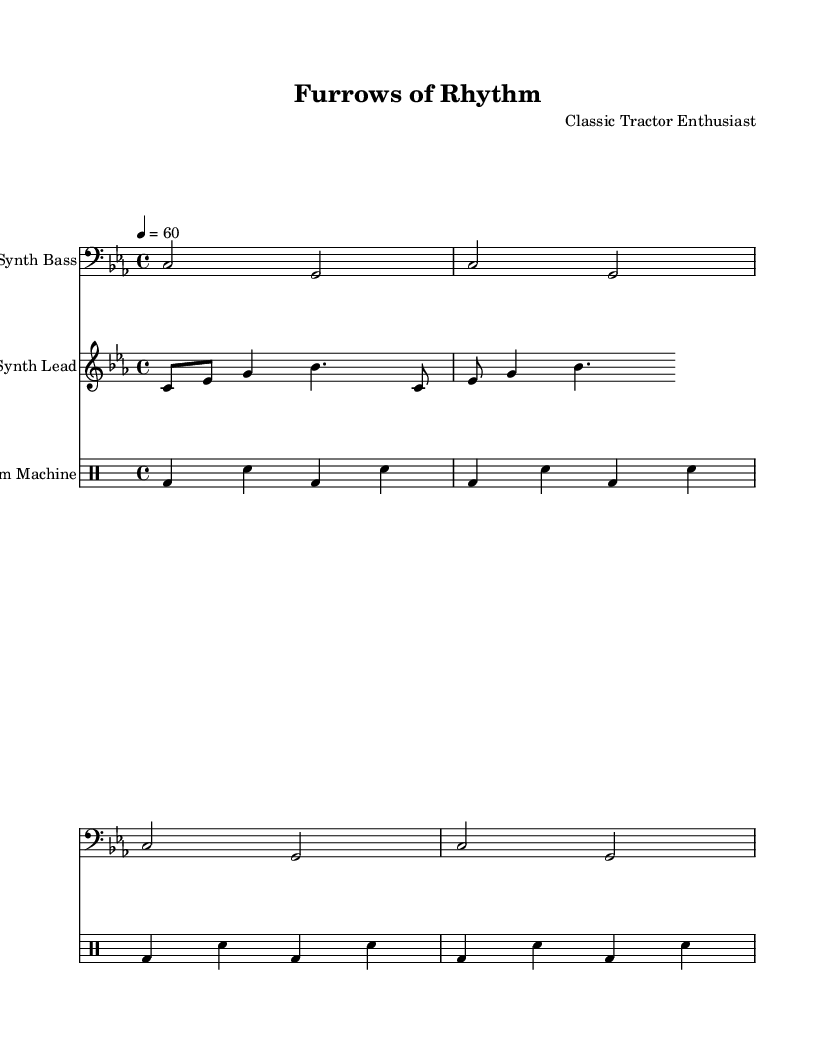What is the key signature of this music? The key signature is indicated at the beginning of the score, which shows C minor, represented by three flats.
Answer: C minor What is the time signature of this piece? The time signature can be found at the beginning of the score, showing 4 over 4, meaning there are four beats per measure.
Answer: 4/4 What is the tempo marking for this composition? The tempo marking appears at the start with a metronome marking of quarter note equals sixty, indicating the speed of the piece.
Answer: 60 How many measures are there in the drum pattern? The drum parts demonstrate a repeated section that unfolds four times, indicating there are four measures total in the pattern.
Answer: 4 What instruments are included in this score? The score lists three staves: Synth Bass, Synth Lead, and Drum Machine, which collectively provide the instrumentation for the piece.
Answer: Synth Bass, Synth Lead, Drum Machine What rhythmic pattern does the drum machine follow? The drum rhythm is shown through the repeated sequence of bass drums and snare, specifically stated as bass drum, snare, bass drum, snare.
Answer: bass drum, snare, bass drum, snare Why might the composer choose to use synthesizer sounds in this piece? The use of synthesizer sounds likely creates an experimental feel suitable for minimalist electronic music, focusing on evoking rhythmic patterns reminiscent of plowing fields.
Answer: experimental feel 